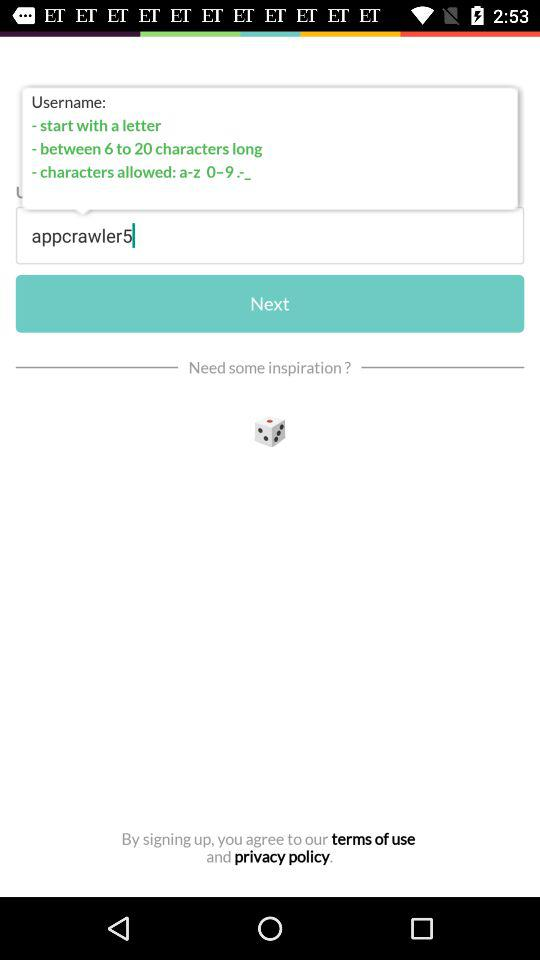What is the username? The username is "appcrawler5". 